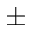Convert formula to latex. <formula><loc_0><loc_0><loc_500><loc_500>\pm</formula> 